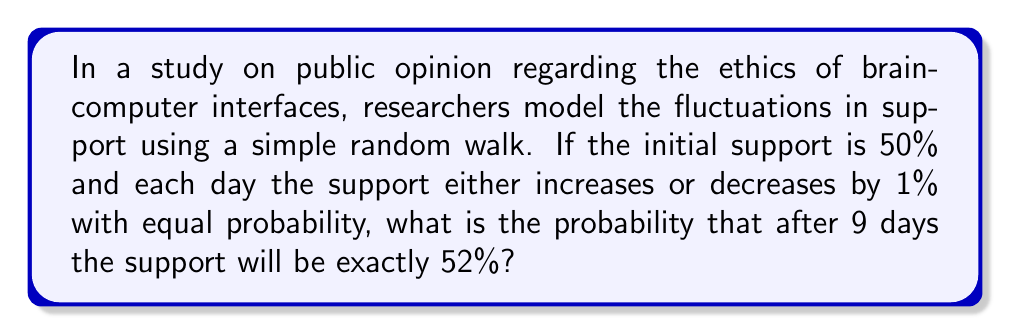What is the answer to this math problem? Let's approach this step-by-step:

1) This is a simple random walk problem. We start at 50% and need to end at 52% after 9 steps.

2) To get from 50% to 52%, we need a net increase of 2%.

3) Let $X$ be the number of steps up. Then $9-X$ is the number of steps down.

4) For a net increase of 2, we need: $X - (9-X) = 2$

5) Solving this equation:
   $X - 9 + X = 2$
   $2X = 11$
   $X = 5.5$

6) Since $X$ must be an integer, there's no solution where we end exactly at 52%.

7) However, we can reach 52% by having 5 steps up and 4 steps down, then 6 steps up and 3 steps down, and so on.

8) The probability of each specific path is $(\frac{1}{2})^9$, as each step has a probability of $\frac{1}{2}$.

9) The number of ways to choose $k$ steps out of 9 is given by the binomial coefficient $\binom{9}{k}$.

10) Therefore, the probability is:

    $$P(\text{52% after 9 days}) = \binom{9}{5}(\frac{1}{2})^9 + \binom{9}{6}(\frac{1}{2})^9 + \binom{9}{7}(\frac{1}{2})^9$$

11) Calculating:
    $$= (126 + 84 + 36) \cdot (\frac{1}{2})^9 = 246 \cdot (\frac{1}{2})^9 = \frac{246}{512} = \frac{123}{256} \approx 0.4805$$
Answer: $\frac{123}{256}$ 